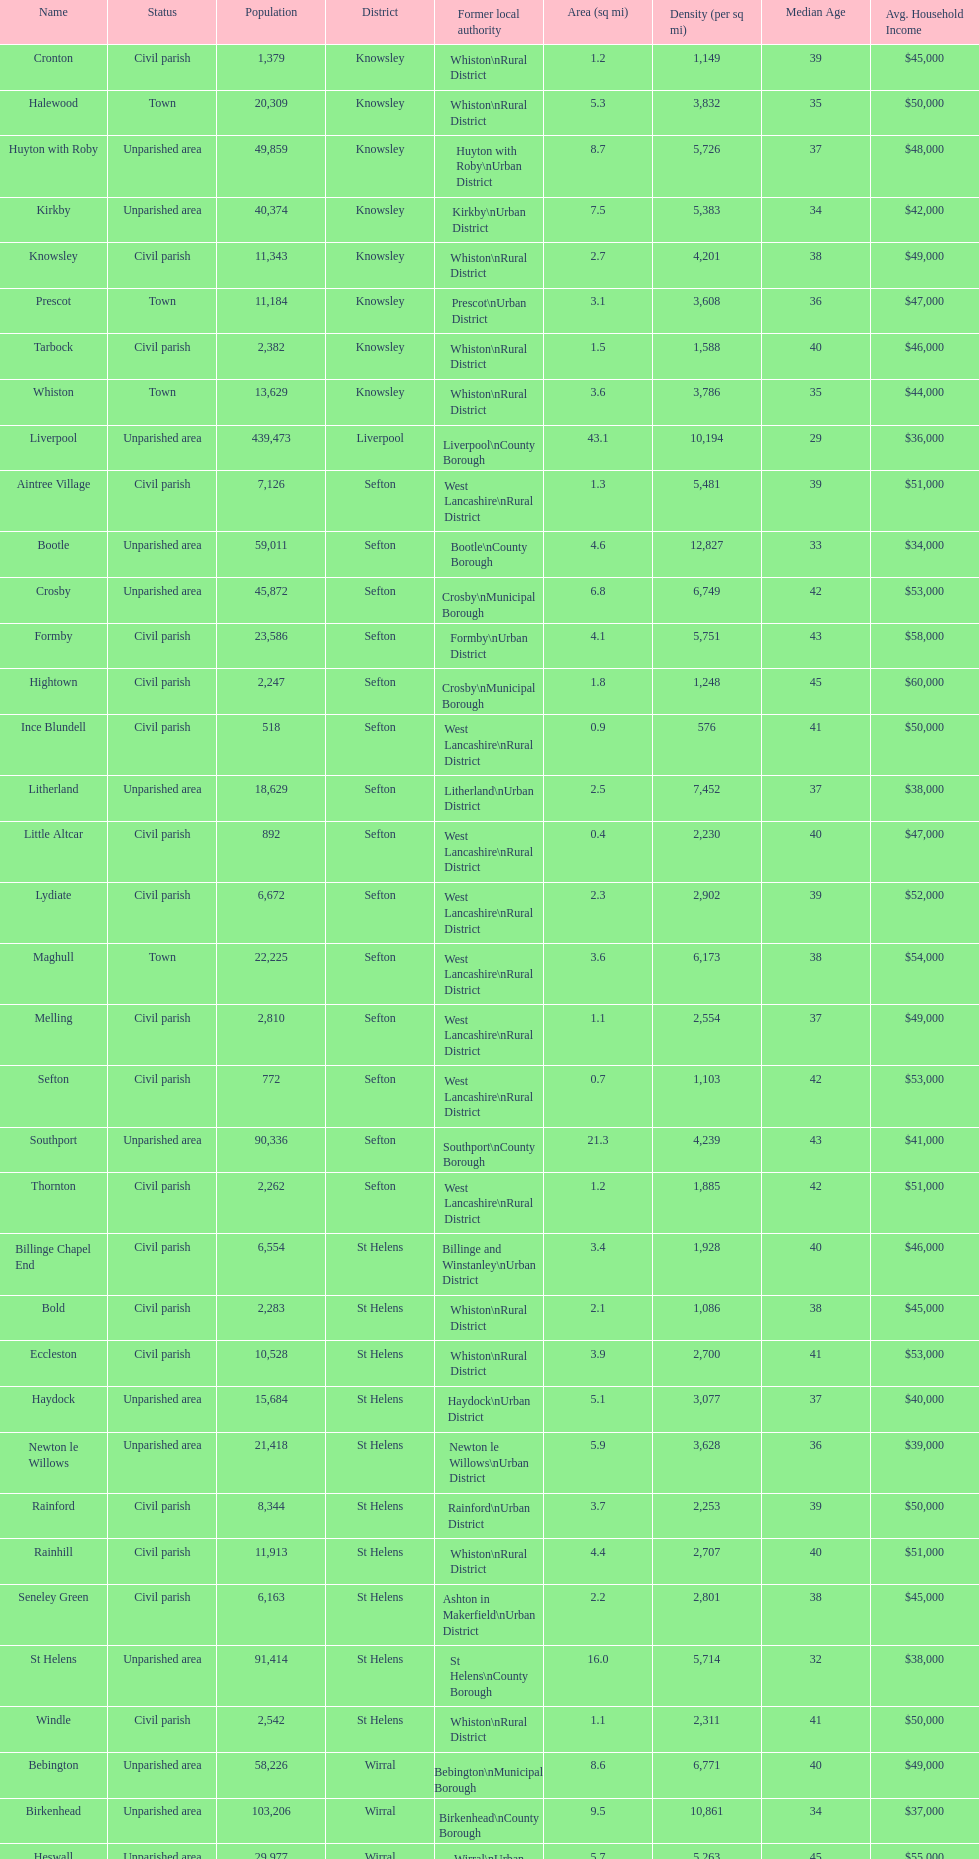Which area has the least number of residents? Ince Blundell. 